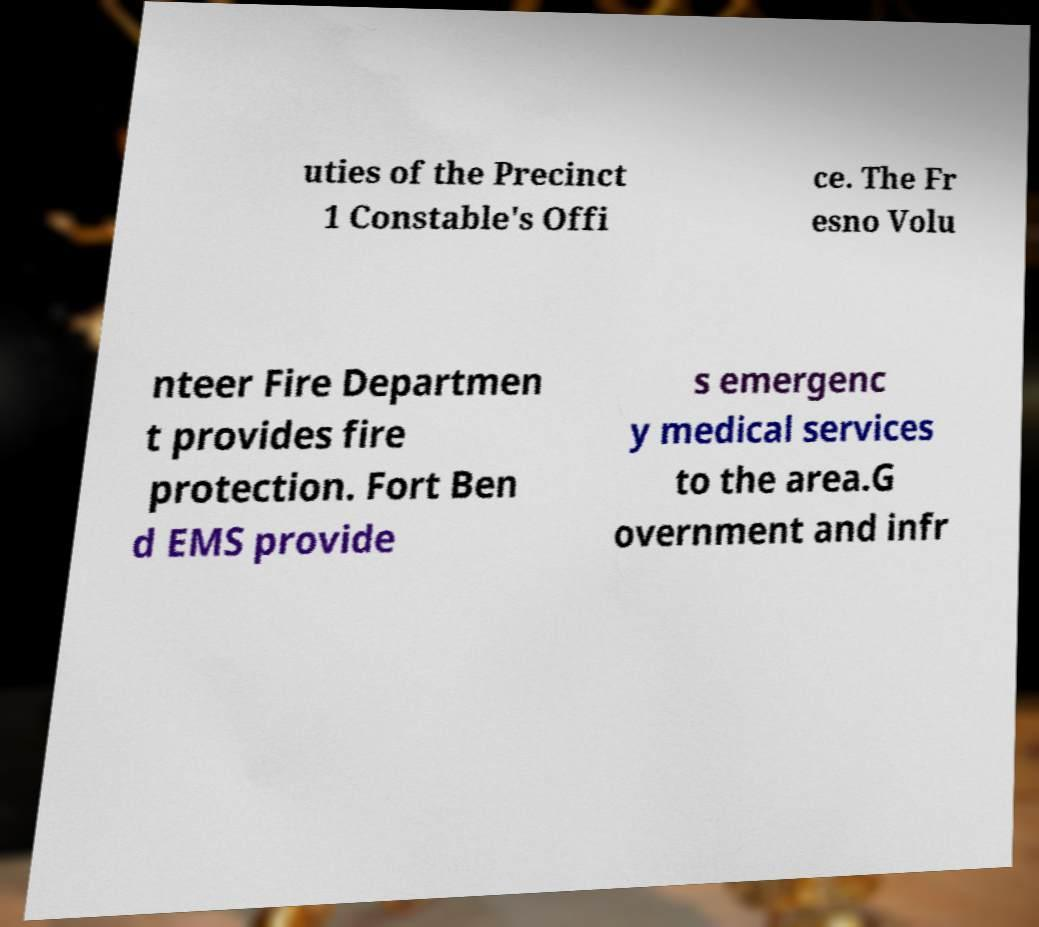I need the written content from this picture converted into text. Can you do that? uties of the Precinct 1 Constable's Offi ce. The Fr esno Volu nteer Fire Departmen t provides fire protection. Fort Ben d EMS provide s emergenc y medical services to the area.G overnment and infr 